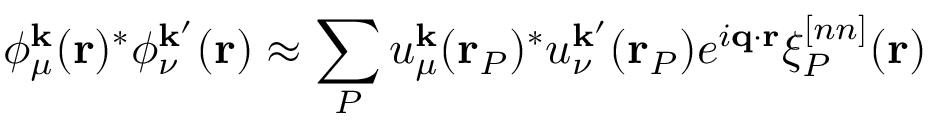<formula> <loc_0><loc_0><loc_500><loc_500>\phi _ { \mu } ^ { k } ( r ) ^ { * } \phi _ { \nu } ^ { k ^ { \prime } } ( r ) \approx \sum _ { P } u _ { \mu } ^ { k } ( r _ { P } ) ^ { * } u _ { \nu } ^ { k ^ { \prime } } ( r _ { P } ) e ^ { i q \cdot r } \xi _ { P } ^ { [ n n ] } ( r )</formula> 